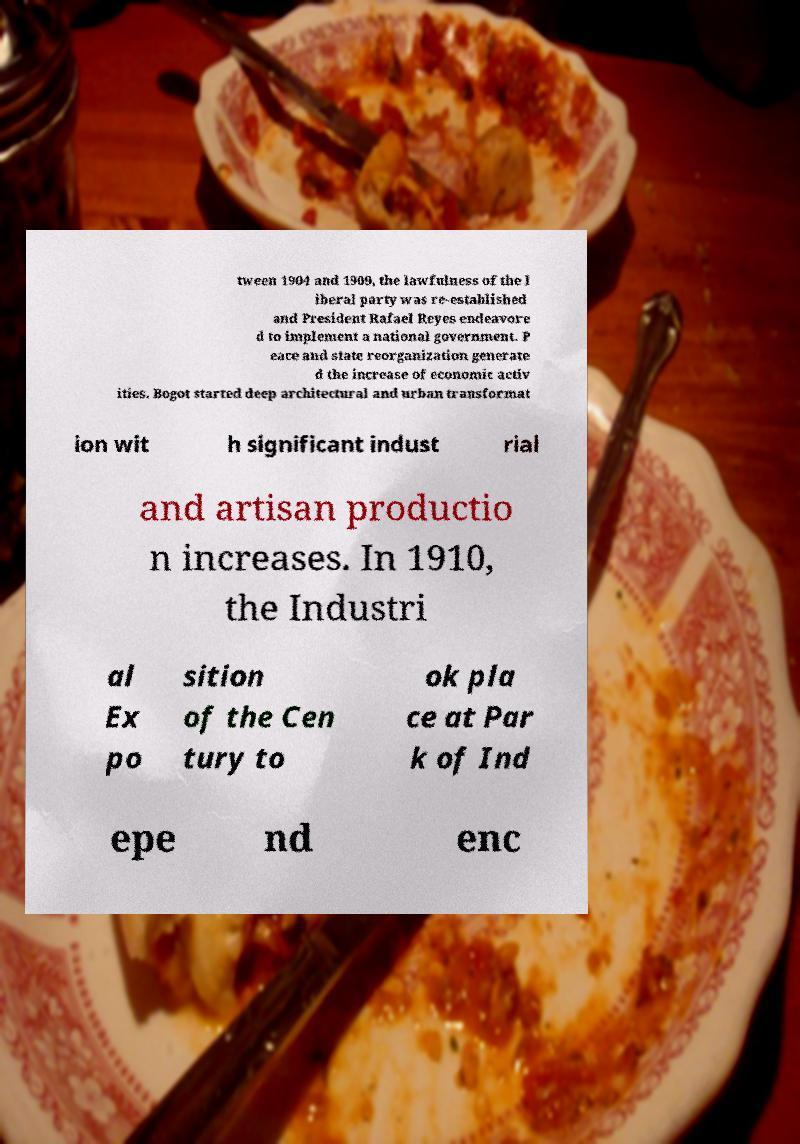Please identify and transcribe the text found in this image. tween 1904 and 1909, the lawfulness of the l iberal party was re-established and President Rafael Reyes endeavore d to implement a national government. P eace and state reorganization generate d the increase of economic activ ities. Bogot started deep architectural and urban transformat ion wit h significant indust rial and artisan productio n increases. In 1910, the Industri al Ex po sition of the Cen tury to ok pla ce at Par k of Ind epe nd enc 